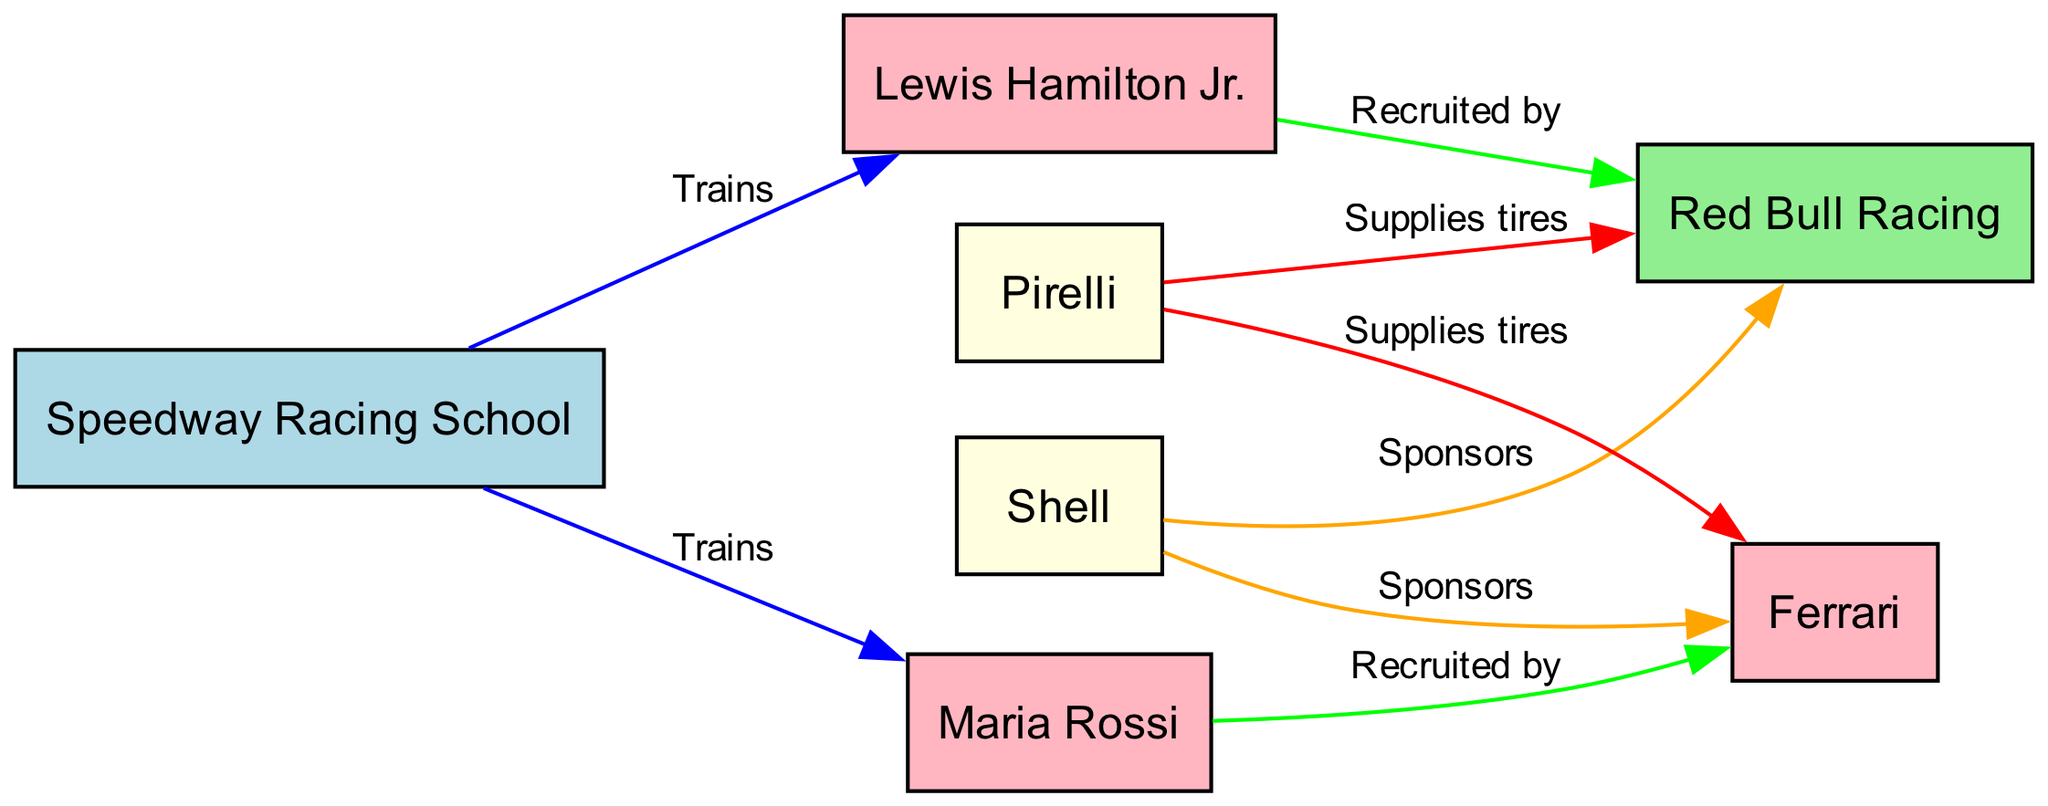What is the total number of nodes in the diagram? The diagram lists the nodes: Speedway Racing School, Lewis Hamilton Jr., Maria Rossi, Red Bull Racing, Ferrari, Shell, and Pirelli. Counting these gives a total of seven nodes.
Answer: 7 Who does Lewis Hamilton Jr. train with? The diagram shows a directed edge labeled "Trains" from Speedway Racing School to Lewis Hamilton Jr., indicating that Lewis Hamilton Jr. is trained at the Speedway Racing School.
Answer: Speedway Racing School Which racing team is sponsored by Shell? There is a directed edge labeled "Sponsors" from Shell to Ferrari in the diagram. Therefore, it indicates that Shell sponsors Ferrari.
Answer: Ferrari How many students are recruited by racing teams? The diagram provides two edges labeled "Recruited by": one from Lewis Hamilton Jr. to Red Bull Racing and another from Maria Rossi to Ferrari. This sums up to a total of two students who are recruited.
Answer: 2 Which team does Maria Rossi join? The edge shows that Maria Rossi is linked to Ferrari through the relationship labeled "Recruited by". This implies that Maria Rossi joins Ferrari as a racer.
Answer: Ferrari What is the relationship between Speedway Racing School and Maria Rossi? The diagram shows a directed edge labeled "Trains" from Speedway Racing School to Maria Rossi. This suggests that the relationship between them is one of training.
Answer: Trains Which tires supplier is associated with Red Bull Racing? The diagram indicates there is an edge from Pirelli to Red Bull Racing labeled "Supplies tires". This means that Pirelli is the supplier of tires for Red Bull Racing.
Answer: Pirelli How many sponsors are there in the diagram? The diagram shows two edges labeled "Sponsors": one from Shell to Red Bull Racing and one from Shell to Ferrari. Thus, there is a total of one sponsor.
Answer: 1 What color indicates the Speedway Racing School in the diagram? According to the node color coding provided in the code, the Speedway Racing School node is indicated with a light blue fill color.
Answer: Light blue 